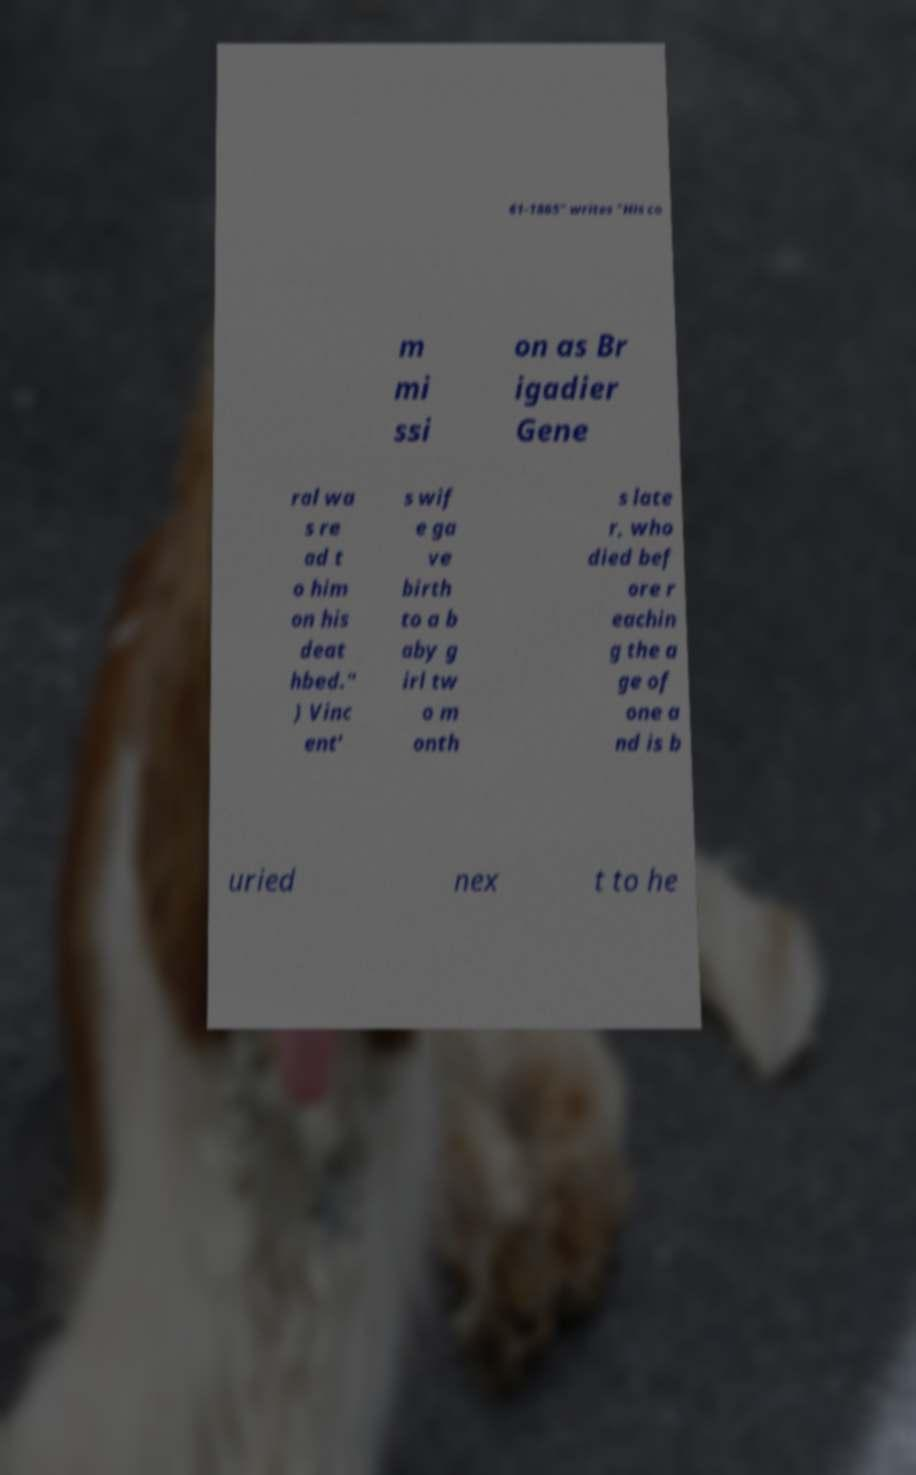For documentation purposes, I need the text within this image transcribed. Could you provide that? 61-1865" writes "His co m mi ssi on as Br igadier Gene ral wa s re ad t o him on his deat hbed." ) Vinc ent' s wif e ga ve birth to a b aby g irl tw o m onth s late r, who died bef ore r eachin g the a ge of one a nd is b uried nex t to he 